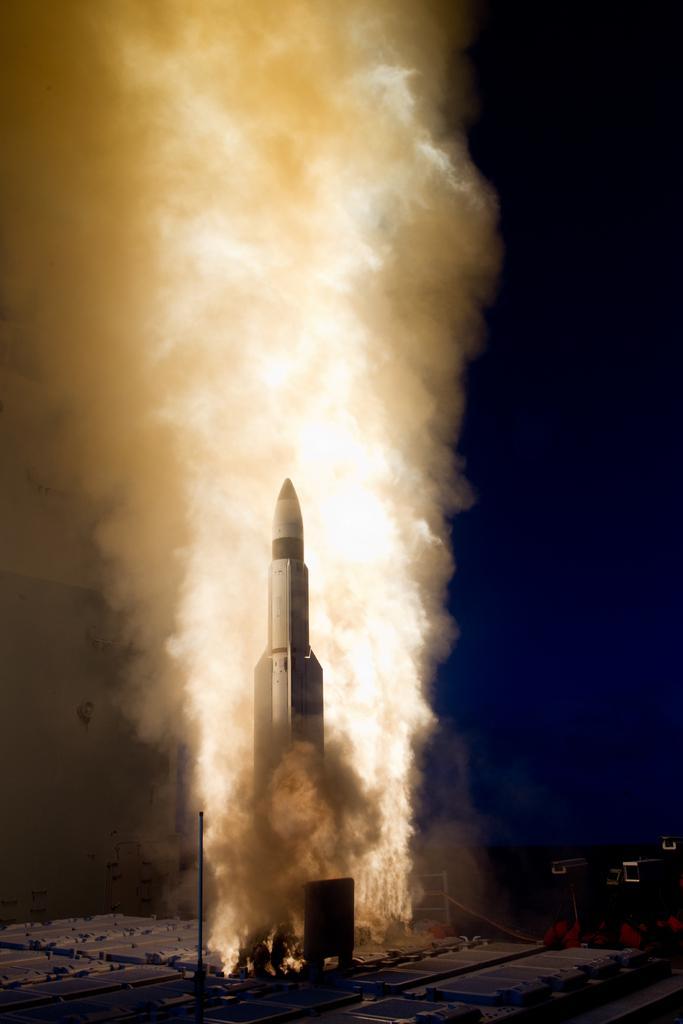Could you give a brief overview of what you see in this image? In this image we can see the rocket launch. We can also see there is a fire and smoke around it 